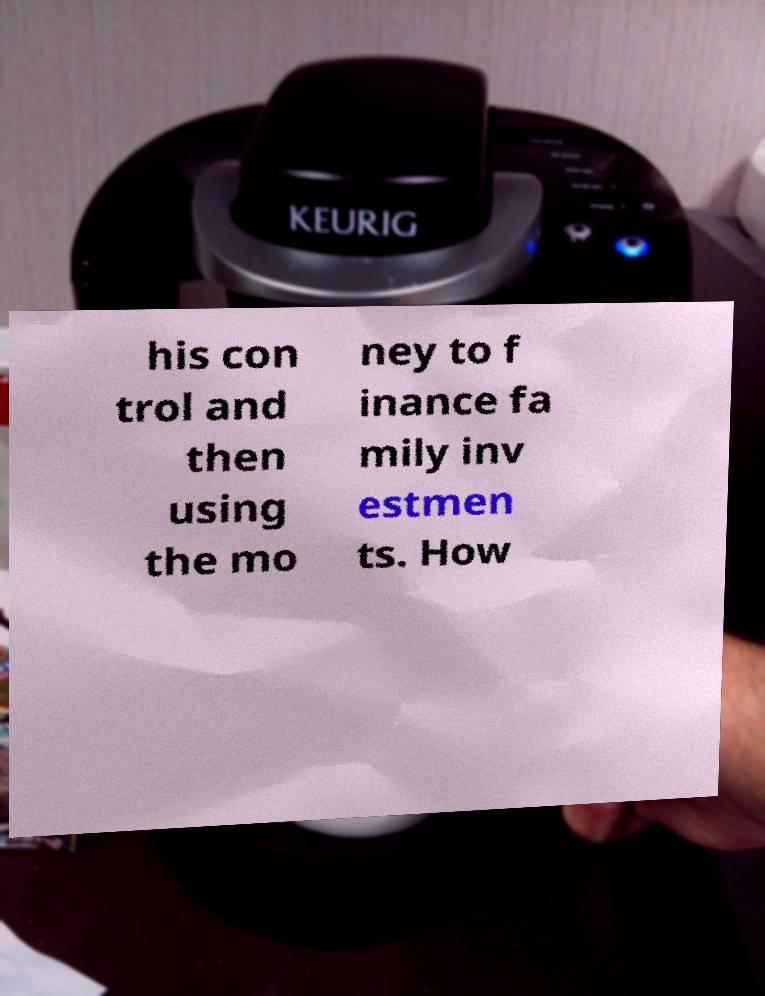What messages or text are displayed in this image? I need them in a readable, typed format. his con trol and then using the mo ney to f inance fa mily inv estmen ts. How 